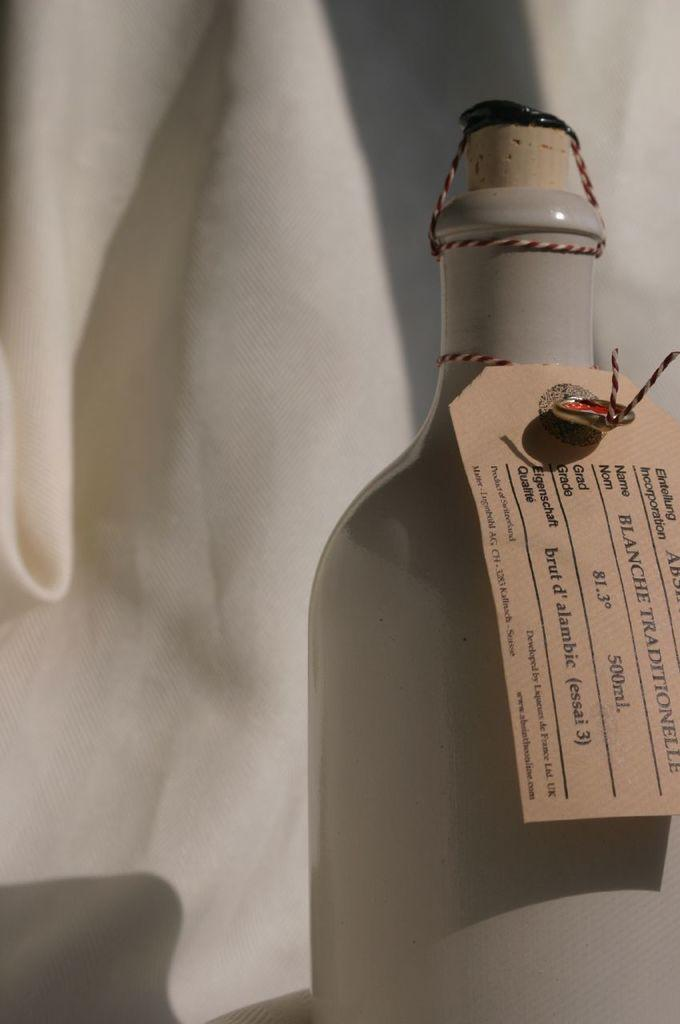<image>
Share a concise interpretation of the image provided. a bottle with a tag on it that reads 'blanche traditionelle' 